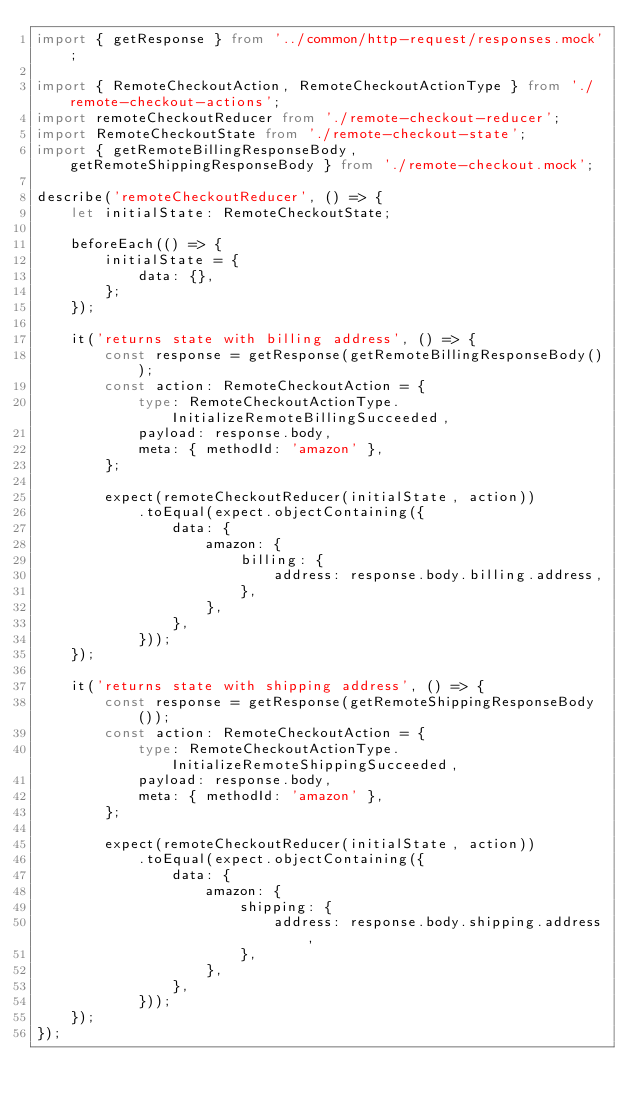Convert code to text. <code><loc_0><loc_0><loc_500><loc_500><_TypeScript_>import { getResponse } from '../common/http-request/responses.mock';

import { RemoteCheckoutAction, RemoteCheckoutActionType } from './remote-checkout-actions';
import remoteCheckoutReducer from './remote-checkout-reducer';
import RemoteCheckoutState from './remote-checkout-state';
import { getRemoteBillingResponseBody, getRemoteShippingResponseBody } from './remote-checkout.mock';

describe('remoteCheckoutReducer', () => {
    let initialState: RemoteCheckoutState;

    beforeEach(() => {
        initialState = {
            data: {},
        };
    });

    it('returns state with billing address', () => {
        const response = getResponse(getRemoteBillingResponseBody());
        const action: RemoteCheckoutAction = {
            type: RemoteCheckoutActionType.InitializeRemoteBillingSucceeded,
            payload: response.body,
            meta: { methodId: 'amazon' },
        };

        expect(remoteCheckoutReducer(initialState, action))
            .toEqual(expect.objectContaining({
                data: {
                    amazon: {
                        billing: {
                            address: response.body.billing.address,
                        },
                    },
                },
            }));
    });

    it('returns state with shipping address', () => {
        const response = getResponse(getRemoteShippingResponseBody());
        const action: RemoteCheckoutAction = {
            type: RemoteCheckoutActionType.InitializeRemoteShippingSucceeded,
            payload: response.body,
            meta: { methodId: 'amazon' },
        };

        expect(remoteCheckoutReducer(initialState, action))
            .toEqual(expect.objectContaining({
                data: {
                    amazon: {
                        shipping: {
                            address: response.body.shipping.address,
                        },
                    },
                },
            }));
    });
});
</code> 